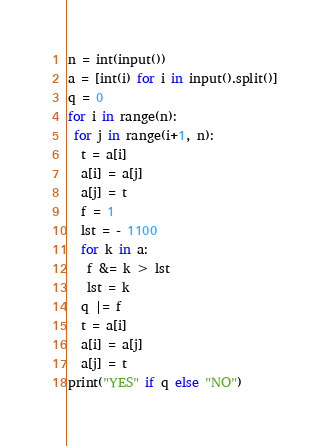Convert code to text. <code><loc_0><loc_0><loc_500><loc_500><_Python_>n = int(input())
a = [int(i) for i in input().split()]
q = 0
for i in range(n):
 for j in range(i+1, n):
  t = a[i]
  a[i] = a[j]
  a[j] = t
  f = 1  
  lst = - 1100
  for k in a:
   f &= k > lst
   lst = k
  q |= f
  t = a[i]
  a[i] = a[j]
  a[j] = t
print("YES" if q else "NO")
</code> 